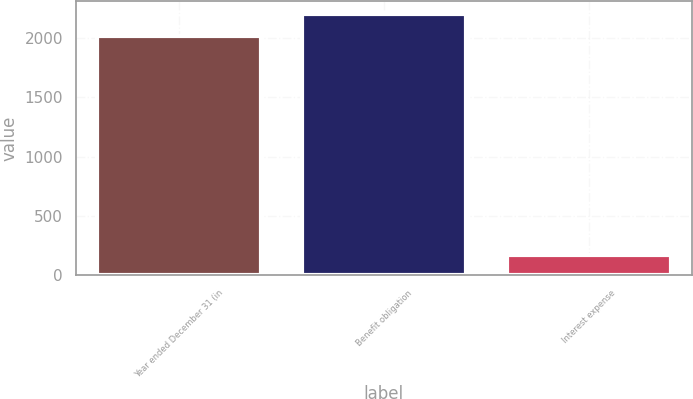Convert chart to OTSL. <chart><loc_0><loc_0><loc_500><loc_500><bar_chart><fcel>Year ended December 31 (in<fcel>Benefit obligation<fcel>Interest expense<nl><fcel>2015<fcel>2201.7<fcel>171<nl></chart> 